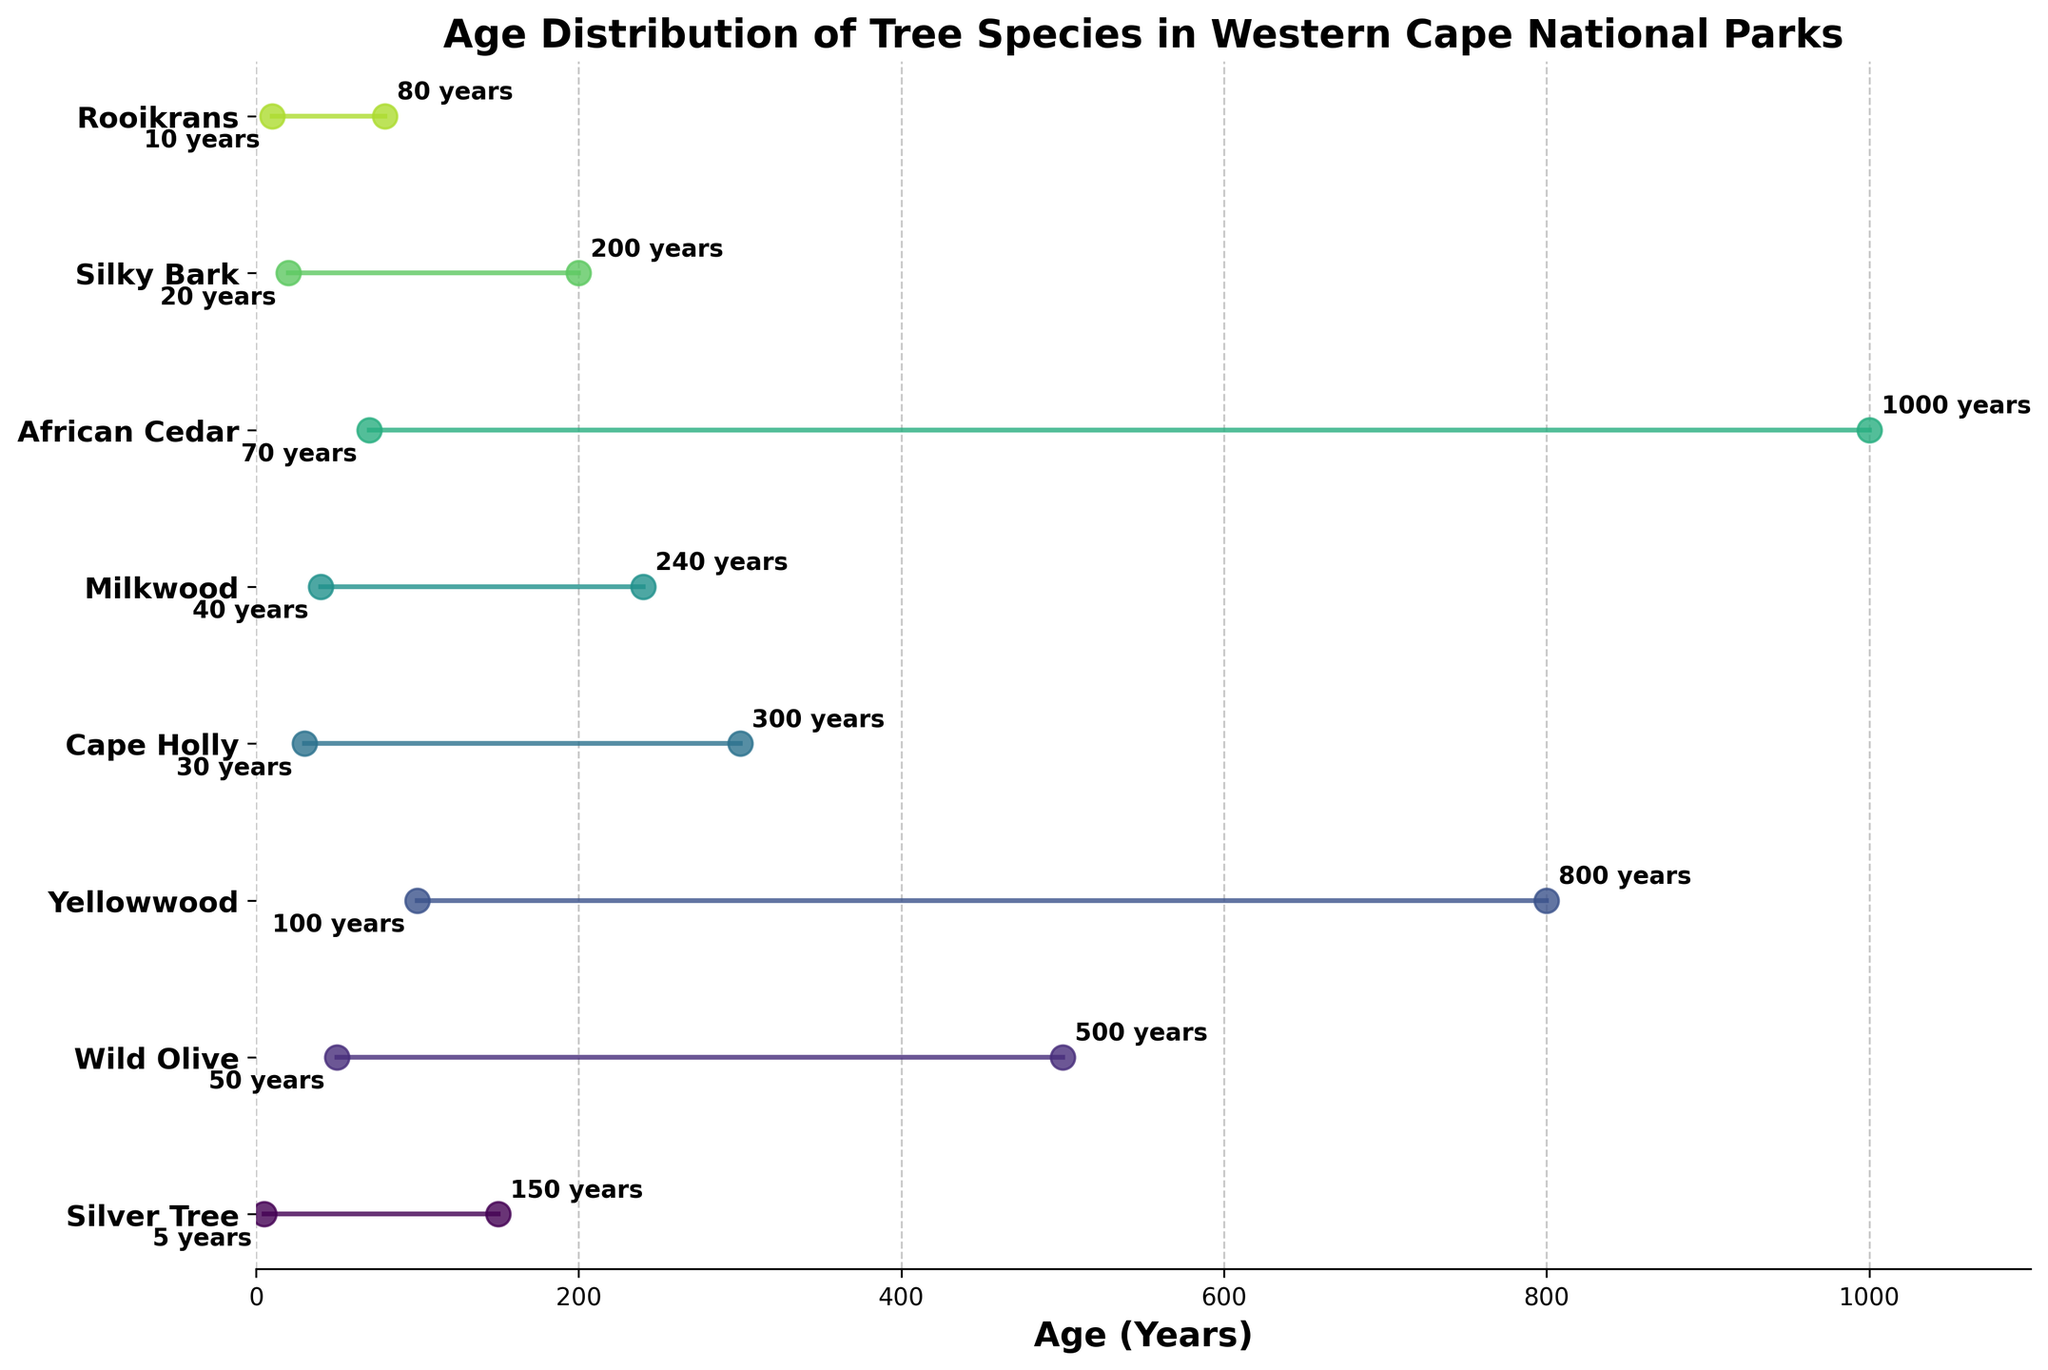What's the minimum age of the Wild Olive trees? The minimum age of the Wild Olive trees can be identified from the left end of the line representing this species. By looking at the position on the x-axis at the start of the Wild Olive line, we see it reads 50 years.
Answer: 50 years Which tree species has the largest age range? To find the species with the largest age range, we need to compare the lengths of the lines representing each species. The African Cedar has the longest line from 70 years to 1000 years.
Answer: African Cedar What is the age range of the Milkwood trees? The age range is calculated by subtracting the minimum age from the maximum age. For Milkwood, the minimum age is 40 years and the maximum age is 240 years. So, the range is 240 - 40 = 200 years.
Answer: 200 years Which tree species is found in Cederberg Wilderness Area? By looking at the labels on the y-axis, we find that the African Cedar is the species located in the Cederberg Wilderness Area.
Answer: African Cedar Do Yellowwood trees live longer than Wild Olive trees? The maximum age of the Yellowwood trees is 800 years, whereas the maximum age of the Wild Olive trees is 500 years. Thus, Yellowwood trees live longer.
Answer: Yes By how many years is the maximum age of Cape Holly different from the maximum age of Silver Tree? The maximum age of Cape Holly is 300 years and the maximum age of Silver Tree is 150 years. The difference is calculated as 300 - 150 = 150 years.
Answer: 150 years What is the total span of ages shown on the plot, from the minimum to the maximum age of all the tree species? The minimum age among all species is 5 years (Silver Tree) and the maximum age is 1000 years (African Cedar). So, the total span is 1000 - 5 = 995 years.
Answer: 995 years Which tree species has the shortest lifespan? The shortest lifespan is determined by the species with the smallest maximum age. The Rooikrans has the shortest maximum age of 80 years.
Answer: Rooikrans What is the average maximum age of the tree species displayed? To find this, add up the maximum ages of all tree species and divide by the number of species: (150 + 500 + 800 + 300 + 240 + 1000 + 200 + 80) / 8 = 3270 / 8 = 408.75 years.
Answer: 408.75 years Which species has a minimum age closest to 50 years? By looking at the minimum age marks, we see Wild Olive has a minimum age of 50 years, which is exactly 50.
Answer: Wild Olive 